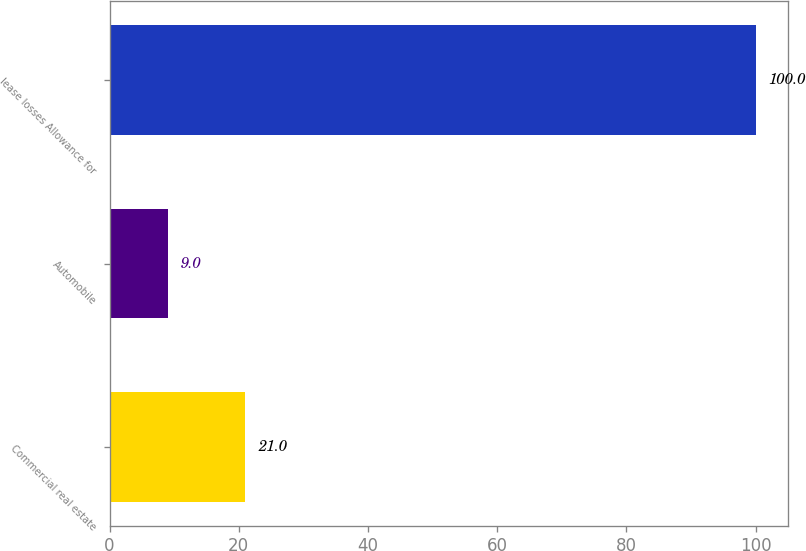Convert chart. <chart><loc_0><loc_0><loc_500><loc_500><bar_chart><fcel>Commercial real estate<fcel>Automobile<fcel>lease losses Allowance for<nl><fcel>21<fcel>9<fcel>100<nl></chart> 